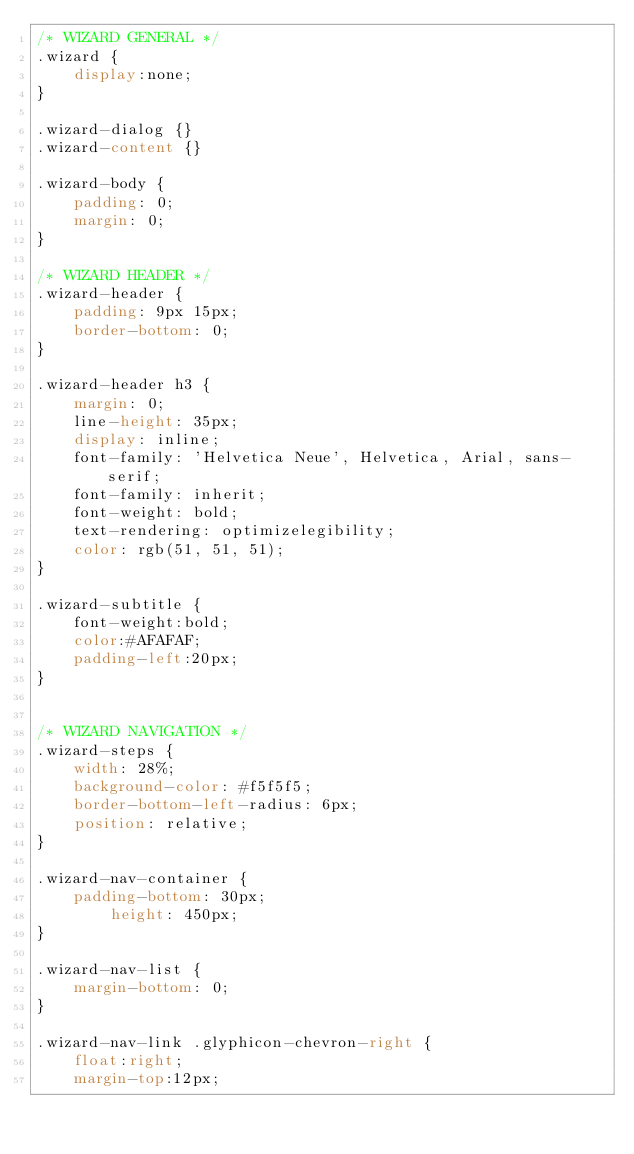<code> <loc_0><loc_0><loc_500><loc_500><_CSS_>/* WIZARD GENERAL */
.wizard {
	display:none;	
}

.wizard-dialog {}
.wizard-content {}

.wizard-body {
	padding: 0;
	margin: 0;
}

/* WIZARD HEADER */
.wizard-header {
	padding: 9px 15px;
	border-bottom: 0;
}

.wizard-header h3 {
	margin: 0;
	line-height: 35px;
	display: inline;
	font-family: 'Helvetica Neue', Helvetica, Arial, sans-serif;
	font-family: inherit;
	font-weight: bold;
	text-rendering: optimizelegibility;
	color: rgb(51, 51, 51);
}

.wizard-subtitle {
	font-weight:bold;
	color:#AFAFAF;
	padding-left:20px;
}


/* WIZARD NAVIGATION */
.wizard-steps {
	width: 28%;
	background-color: #f5f5f5;
	border-bottom-left-radius: 6px;
	position: relative;
}

.wizard-nav-container {
	padding-bottom: 30px;
        height: 450px;
}

.wizard-nav-list {
	margin-bottom: 0;
}

.wizard-nav-link .glyphicon-chevron-right {
	float:right;
	margin-top:12px;</code> 